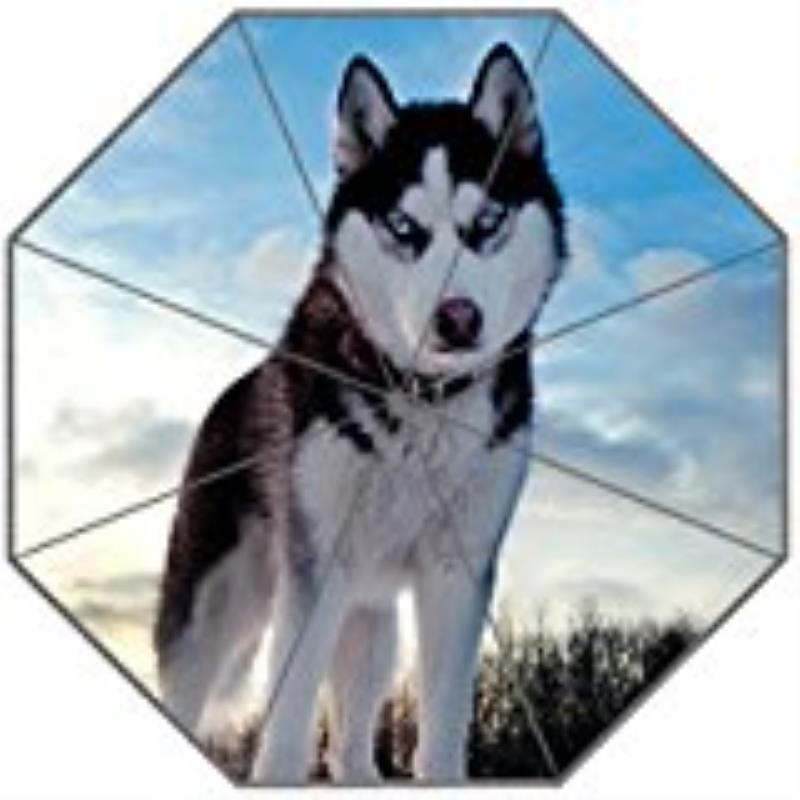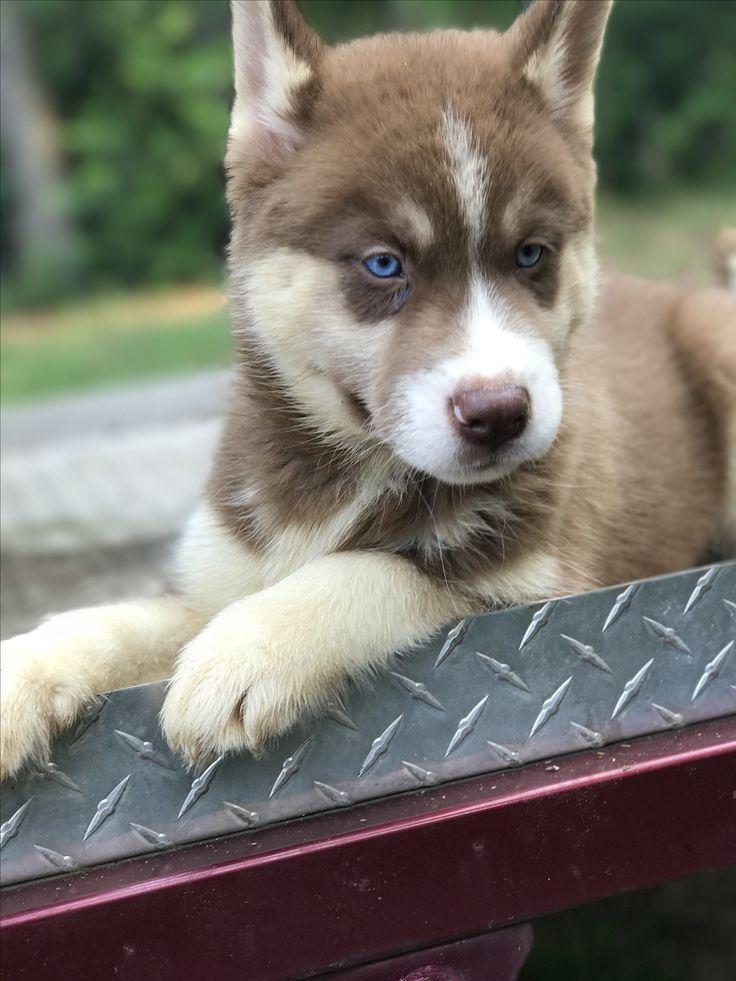The first image is the image on the left, the second image is the image on the right. Considering the images on both sides, is "At least one Malamute is sitting in the snow." valid? Answer yes or no. No. The first image is the image on the left, the second image is the image on the right. Analyze the images presented: Is the assertion "The right image shows a non-standing adult husky dog with its head upright, and the left image shows a husky puppy with its head down but its eyes gazing upward." valid? Answer yes or no. No. 